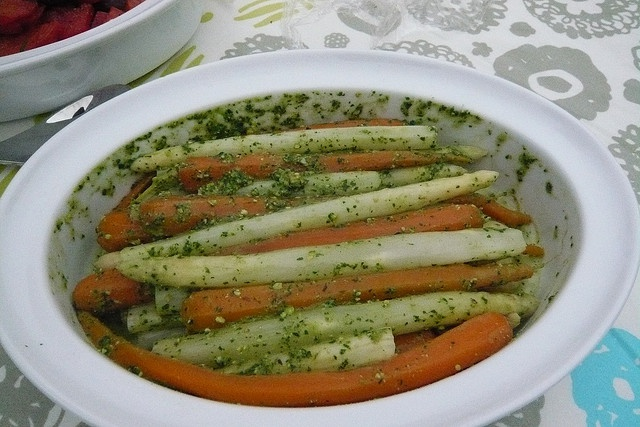Describe the objects in this image and their specific colors. I can see bowl in maroon, lightgray, olive, and brown tones, bowl in maroon, darkgray, gray, and black tones, carrot in maroon, brown, and olive tones, carrot in maroon, olive, and black tones, and carrot in maroon, olive, and black tones in this image. 